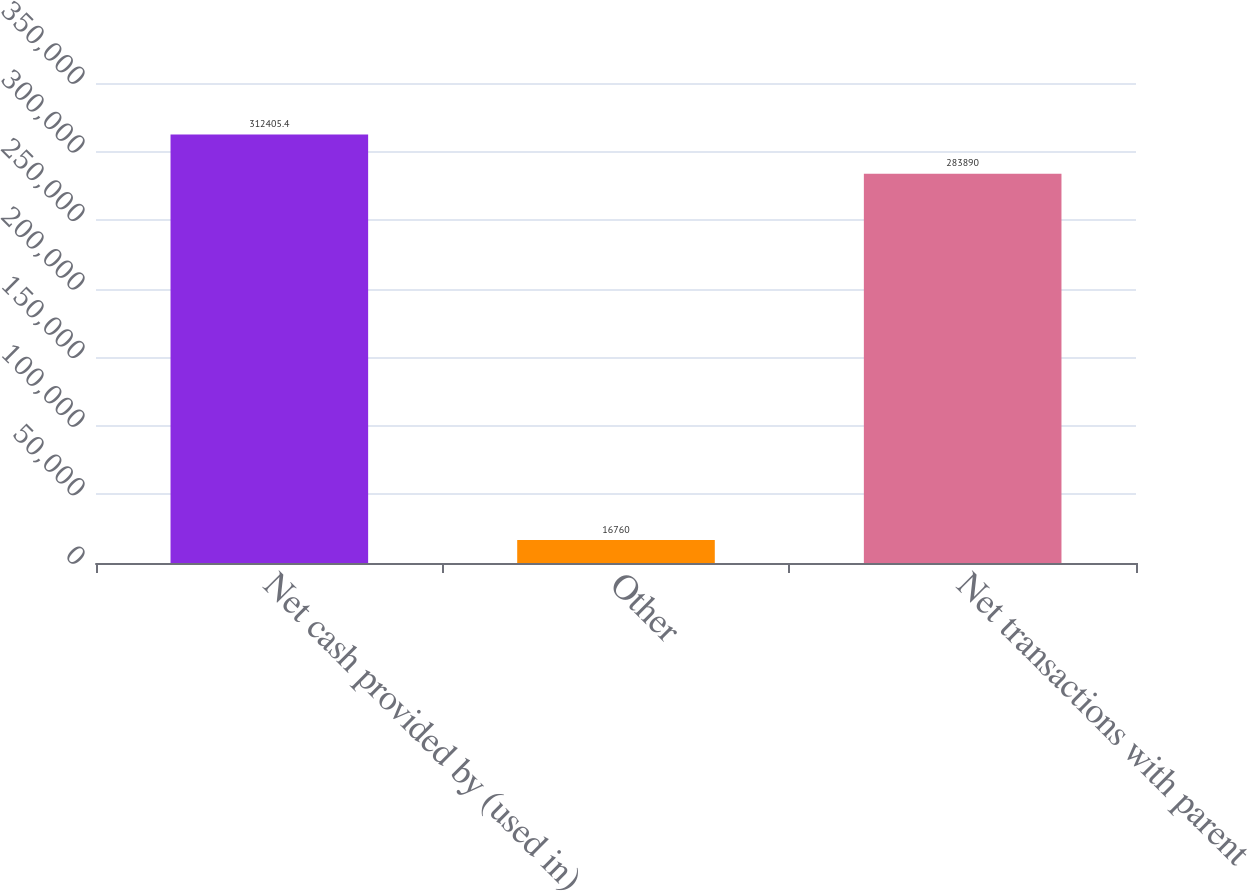Convert chart to OTSL. <chart><loc_0><loc_0><loc_500><loc_500><bar_chart><fcel>Net cash provided by (used in)<fcel>Other<fcel>Net transactions with parent<nl><fcel>312405<fcel>16760<fcel>283890<nl></chart> 